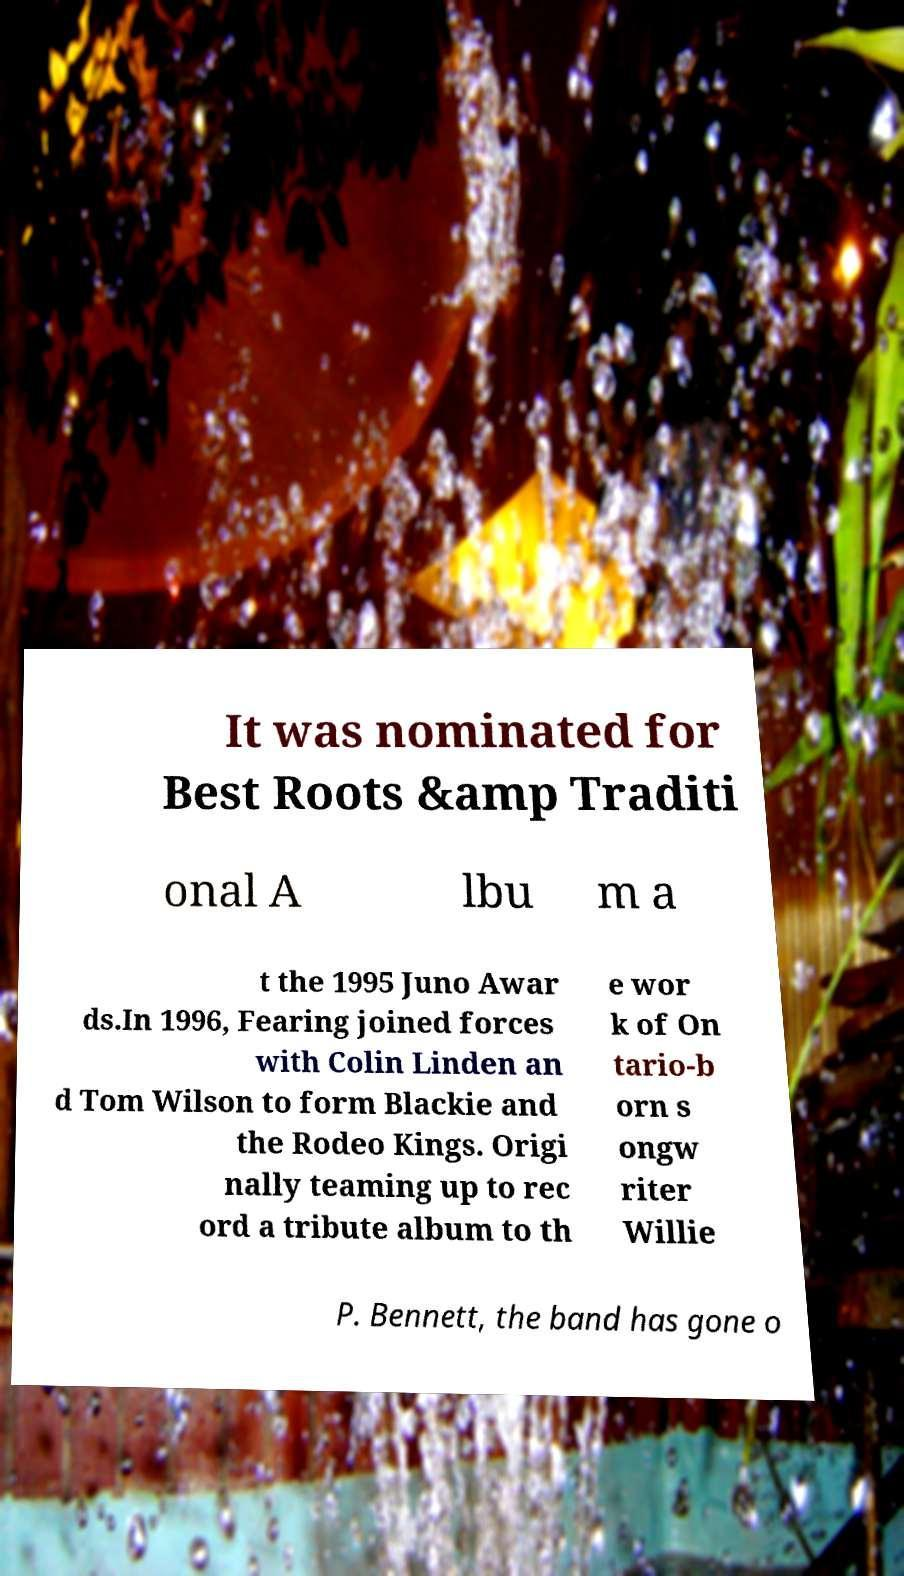Could you assist in decoding the text presented in this image and type it out clearly? It was nominated for Best Roots &amp Traditi onal A lbu m a t the 1995 Juno Awar ds.In 1996, Fearing joined forces with Colin Linden an d Tom Wilson to form Blackie and the Rodeo Kings. Origi nally teaming up to rec ord a tribute album to th e wor k of On tario-b orn s ongw riter Willie P. Bennett, the band has gone o 